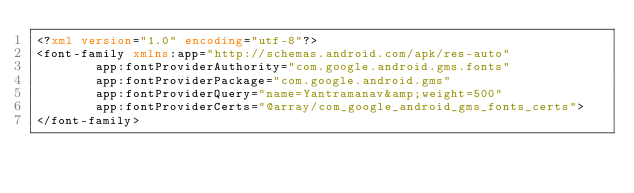Convert code to text. <code><loc_0><loc_0><loc_500><loc_500><_XML_><?xml version="1.0" encoding="utf-8"?>
<font-family xmlns:app="http://schemas.android.com/apk/res-auto"
        app:fontProviderAuthority="com.google.android.gms.fonts"
        app:fontProviderPackage="com.google.android.gms"
        app:fontProviderQuery="name=Yantramanav&amp;weight=500"
        app:fontProviderCerts="@array/com_google_android_gms_fonts_certs">
</font-family>
</code> 